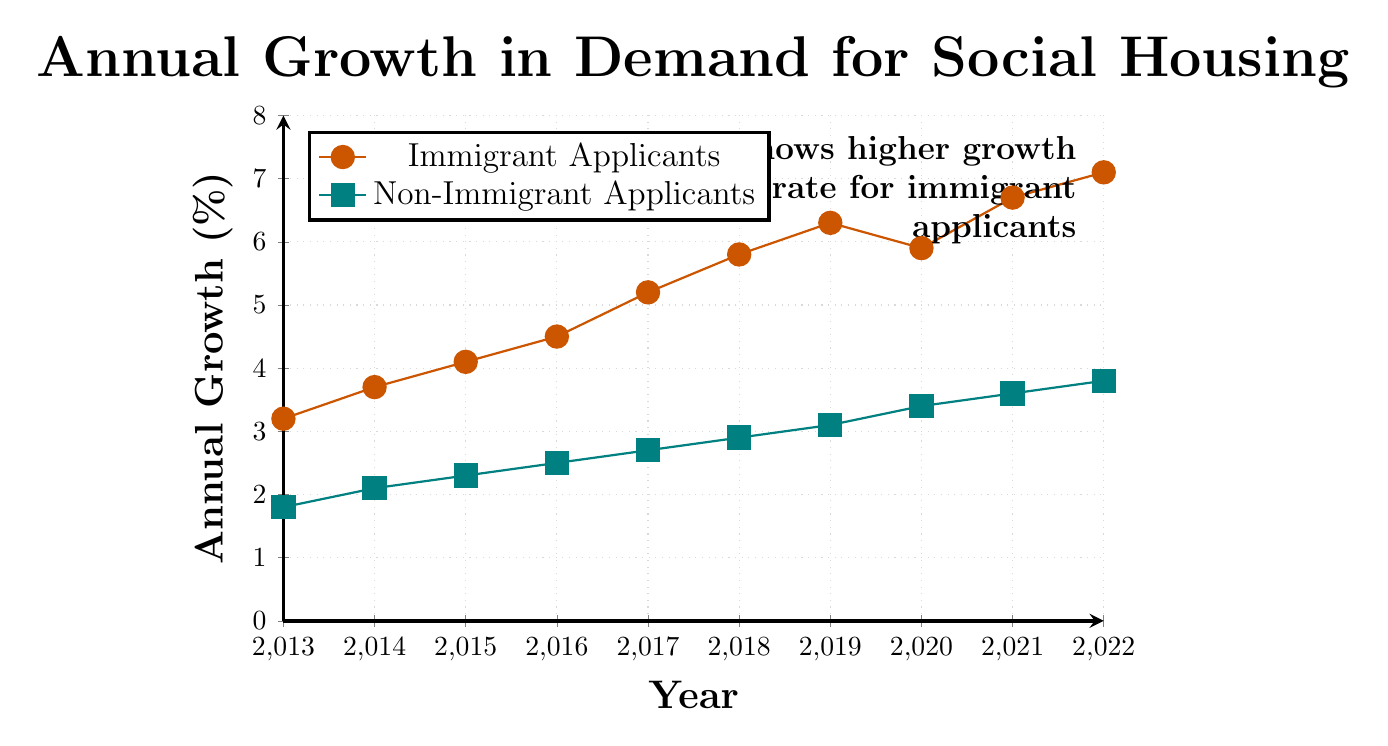What year shows the highest growth rate for immigrant applicants? From the figure, the highest point on the line representing immigrant applicants' growth rate occurs in 2022.
Answer: 2022 What is the difference in growth rates between immigrant and non-immigrant applicants in 2020? The growth rate for immigrant applicants in 2020 is 5.9%, and for non-immigrant applicants, it is 3.4%. The difference is 5.9% - 3.4% = 2.5%.
Answer: 2.5% Compare the growth rate trends for both groups from 2013 to 2022. The trend for immigrant applicants shows a steady increase from 3.2% in 2013 to 7.1% in 2022. For non-immigrant applicants, the trend also shows an increase but at a slower rate, from 1.8% in 2013 to 3.8% in 2022.
Answer: Immigrant applicants have a steeper growth trend than non-immigrant applicants Which year had the smallest difference in growth rates between immigrant and non-immigrant applicants? By visually comparing the lines representing each group, the smallest difference appears in 2013. The growth rates for that year are 3.2% for immigrants and 1.8% for non-immigrants, with a difference of 1.4%.
Answer: 2013 In which year did the immigrant applicants' growth rate decrease compared to the previous year? The decrease in the growth rate for immigrant applicants is observed between 2019 (6.3%) and 2020 (5.9%).
Answer: 2020 What is the overall trend for non-immigrant applicants from 2013 to 2022? The overall trend for non-immigrant applicants shows a gradual increase from 1.8% in 2013 to 3.8% in 2022.
Answer: Gradual increase How does the growth rate of non-immigrant applicants in 2022 compare to that of immigrant applicants in 2014? The non-immigrant applicants' growth rate in 2022 is 3.8%, while the immigrant applicants' growth rate in 2014 is 3.7%. The non-immigrant growth rate in 2022 is slightly higher than the immigrant rate in 2014.
Answer: Slightly higher What average growth rate can be observed for immigrant applicants from 2013 to 2022? To calculate the average, sum all the yearly growth rates for immigrant applicants from 2013 to 2022 and divide by the number of years: (3.2 + 3.7 + 4.1 + 4.5 + 5.2 + 5.8 + 6.3 + 5.9 + 6.7 + 7.1) / 10 = 5.25%.
Answer: 5.25% Between which consecutive years did immigrant applicants' growth rate increase the most? By comparing the year-over-year differences, the largest increase for immigrant applicants is between 2021 (6.7%) and 2022 (7.1%), showing an increase of 0.4%.
Answer: 2021 and 2022 